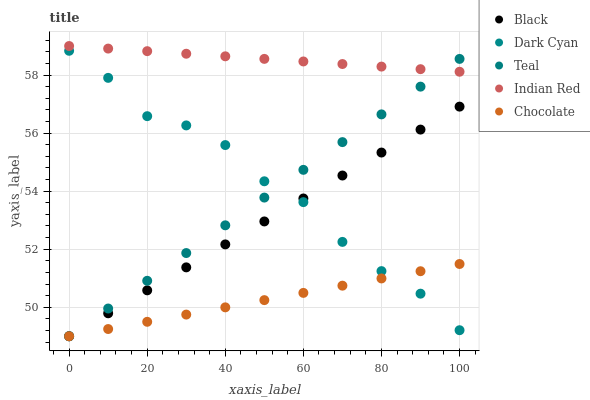Does Chocolate have the minimum area under the curve?
Answer yes or no. Yes. Does Indian Red have the maximum area under the curve?
Answer yes or no. Yes. Does Black have the minimum area under the curve?
Answer yes or no. No. Does Black have the maximum area under the curve?
Answer yes or no. No. Is Black the smoothest?
Answer yes or no. Yes. Is Dark Cyan the roughest?
Answer yes or no. Yes. Is Indian Red the smoothest?
Answer yes or no. No. Is Indian Red the roughest?
Answer yes or no. No. Does Black have the lowest value?
Answer yes or no. Yes. Does Indian Red have the lowest value?
Answer yes or no. No. Does Indian Red have the highest value?
Answer yes or no. Yes. Does Black have the highest value?
Answer yes or no. No. Is Chocolate less than Indian Red?
Answer yes or no. Yes. Is Indian Red greater than Black?
Answer yes or no. Yes. Does Chocolate intersect Dark Cyan?
Answer yes or no. Yes. Is Chocolate less than Dark Cyan?
Answer yes or no. No. Is Chocolate greater than Dark Cyan?
Answer yes or no. No. Does Chocolate intersect Indian Red?
Answer yes or no. No. 